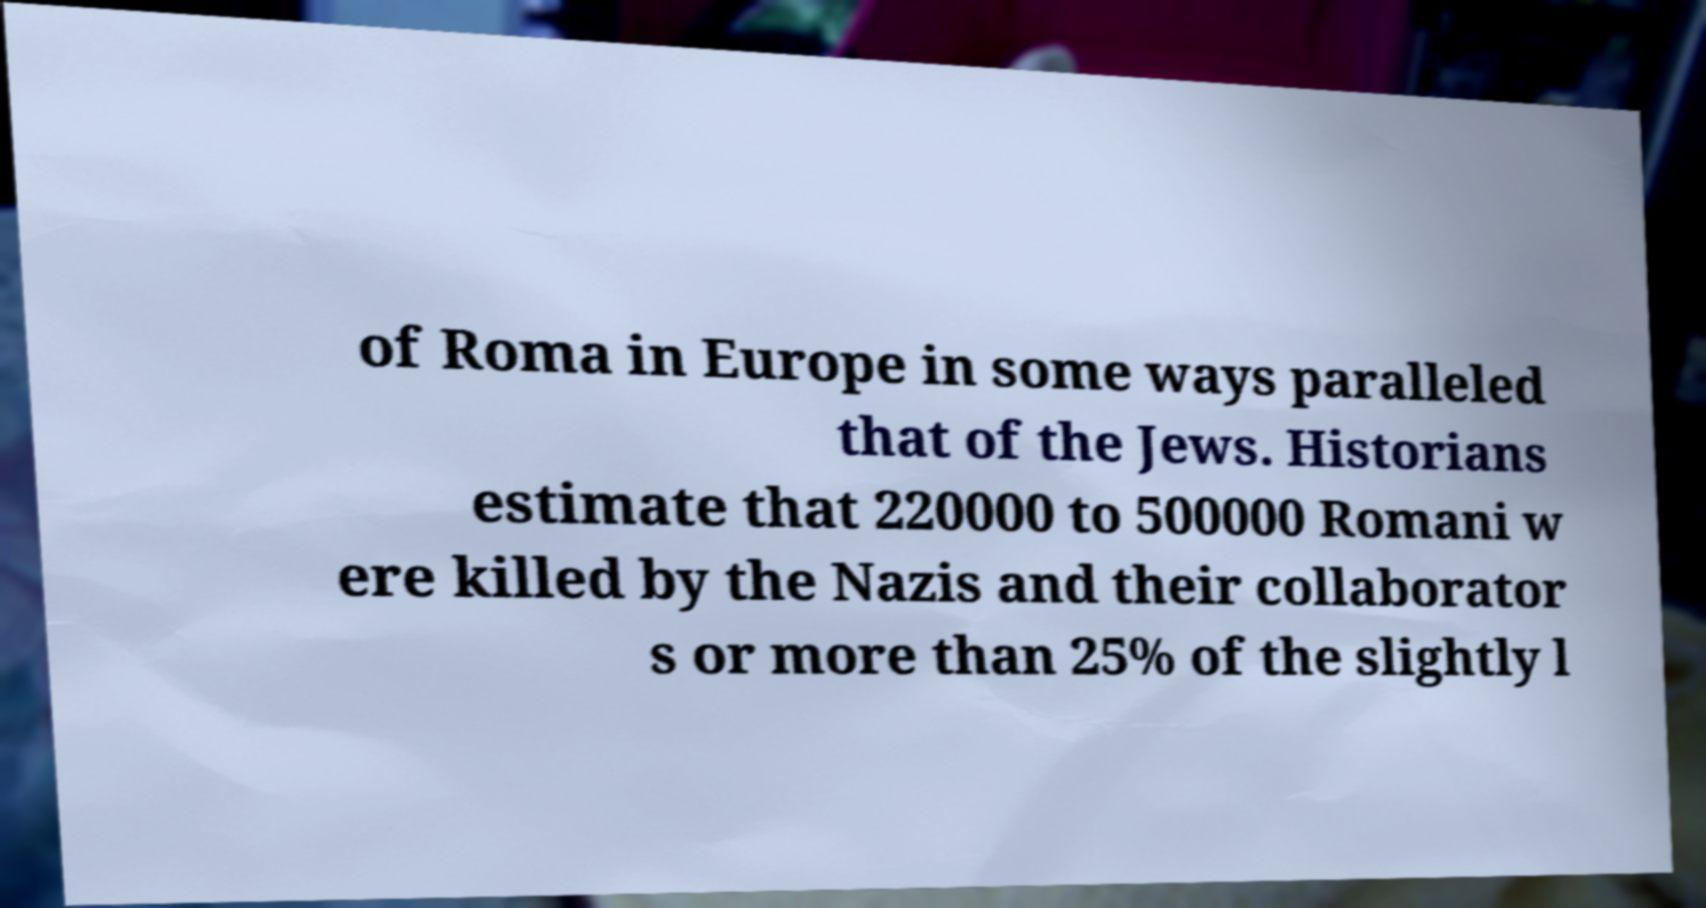For documentation purposes, I need the text within this image transcribed. Could you provide that? of Roma in Europe in some ways paralleled that of the Jews. Historians estimate that 220000 to 500000 Romani w ere killed by the Nazis and their collaborator s or more than 25% of the slightly l 